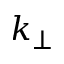<formula> <loc_0><loc_0><loc_500><loc_500>k _ { \perp }</formula> 